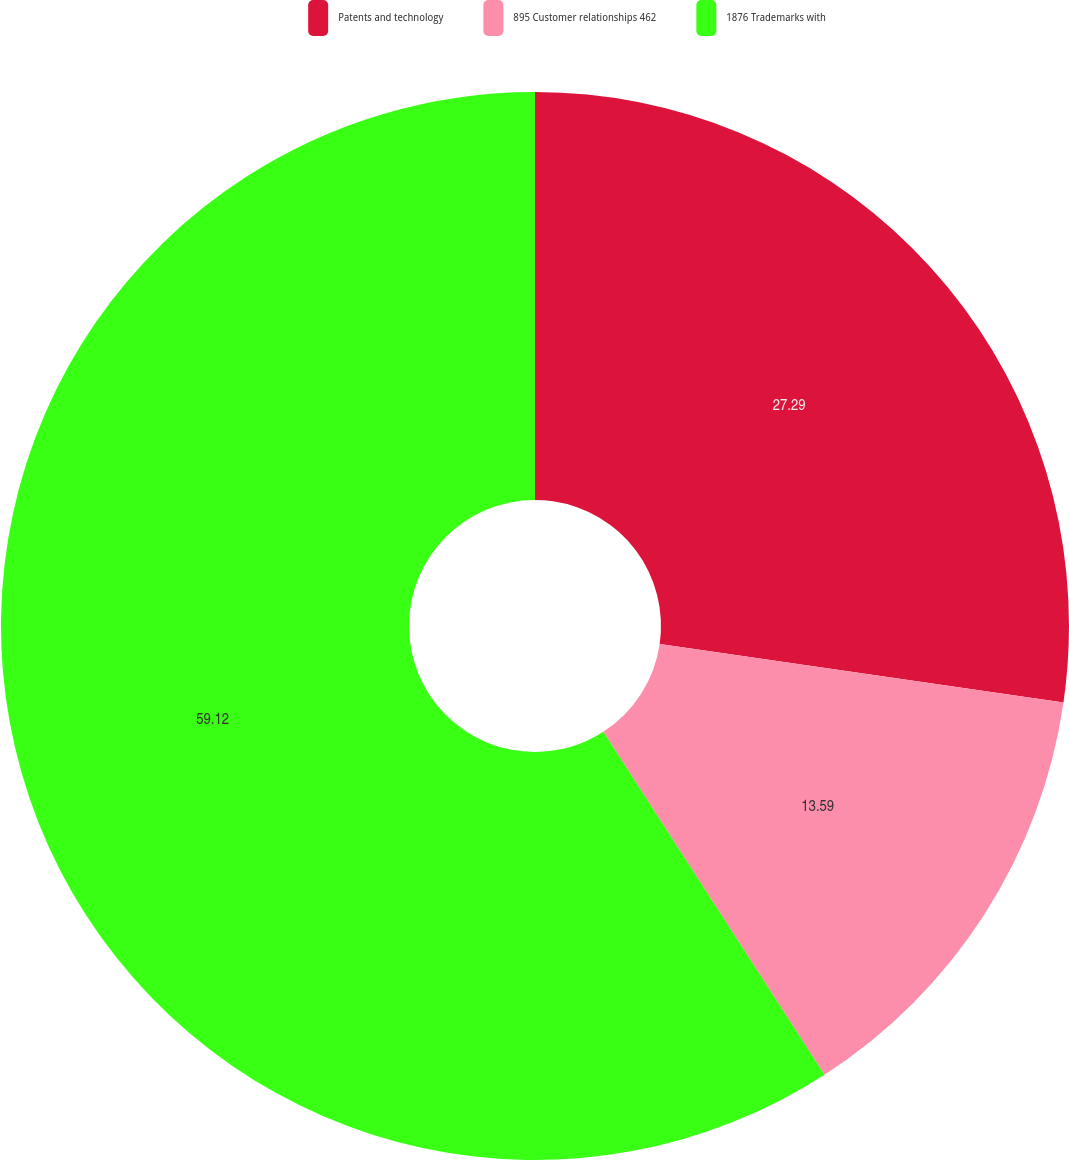<chart> <loc_0><loc_0><loc_500><loc_500><pie_chart><fcel>Patents and technology<fcel>895 Customer relationships 462<fcel>1876 Trademarks with<nl><fcel>27.29%<fcel>13.59%<fcel>59.12%<nl></chart> 